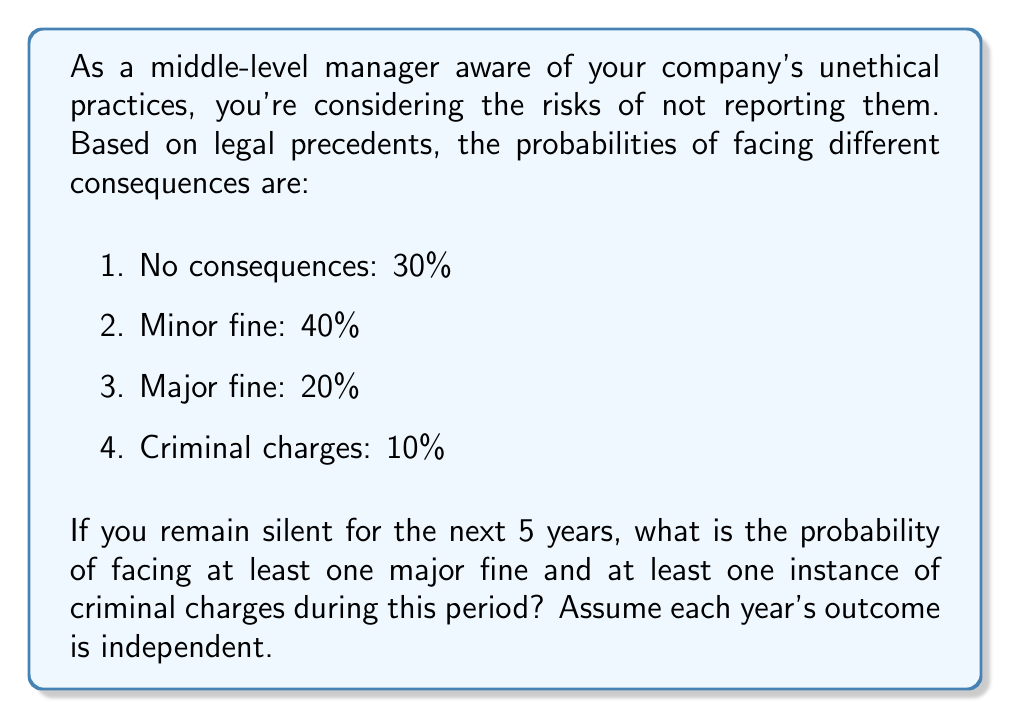Can you answer this question? Let's approach this step-by-step using the multinomial probability distribution:

1) First, we need to calculate the probability of not facing a major fine in a single year:
   $P(\text{no major fine}) = 0.30 + 0.40 + 0.10 = 0.80$

2) The probability of not facing criminal charges in a single year:
   $P(\text{no criminal charges}) = 0.30 + 0.40 + 0.20 = 0.90$

3) Now, the probability of avoiding both major fines and criminal charges for all 5 years is:
   $P(\text{avoid both for 5 years}) = (0.80 \times 0.90)^5 = 0.2373$

4) Therefore, the probability of facing at least one major fine or at least one instance of criminal charges in 5 years is:
   $P(\text{at least one of either}) = 1 - 0.2373 = 0.7627$

5) However, we want the probability of facing at least one of each. This is equivalent to subtracting the probability of avoiding either major fines or criminal charges:

   $P(\text{at least one of each}) = 1 - P(\text{avoid major fines}) - P(\text{avoid criminal charges}) + P(\text{avoid both})$

   $= 1 - (0.80^5) - (0.90^5) + (0.80 \times 0.90)^5$

   $= 1 - 0.32768 - 0.59049 + 0.2373$

   $= 0.31913$

Therefore, the probability of facing at least one major fine and at least one instance of criminal charges over the 5-year period is approximately 0.31913 or 31.913%.
Answer: 0.31913 